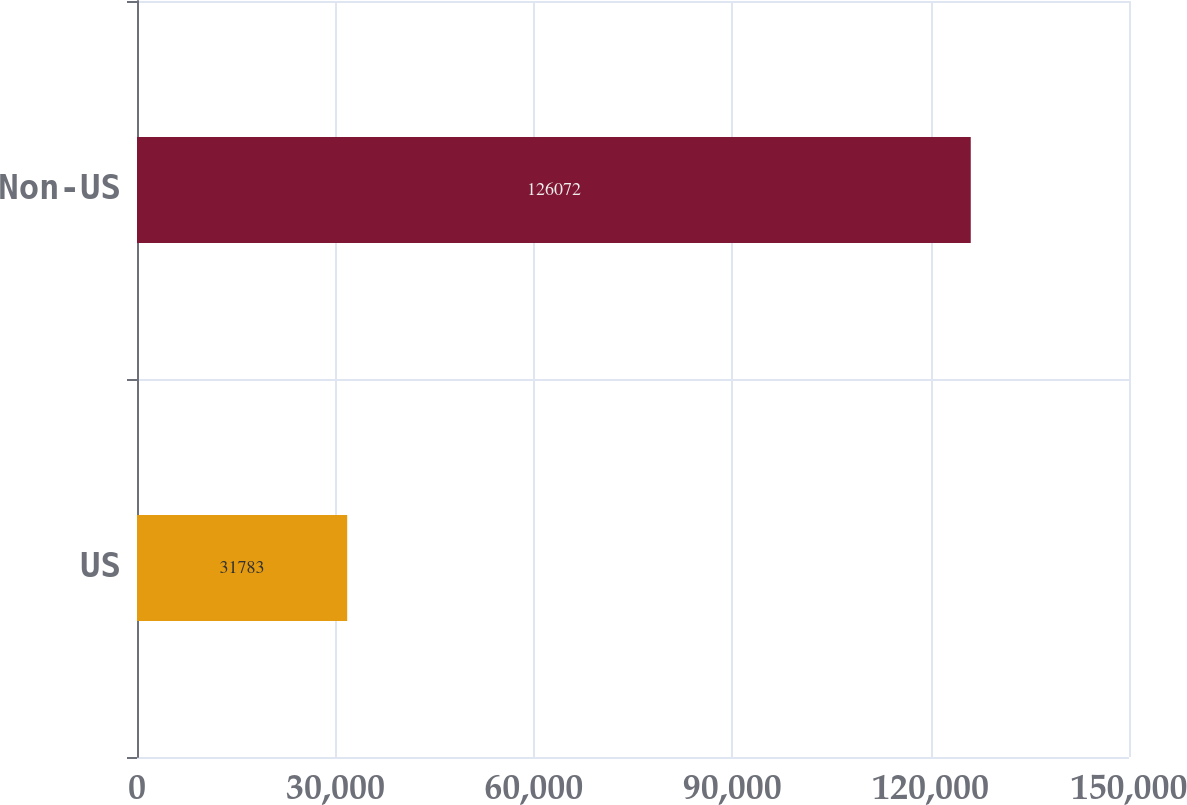Convert chart. <chart><loc_0><loc_0><loc_500><loc_500><bar_chart><fcel>US<fcel>Non-US<nl><fcel>31783<fcel>126072<nl></chart> 